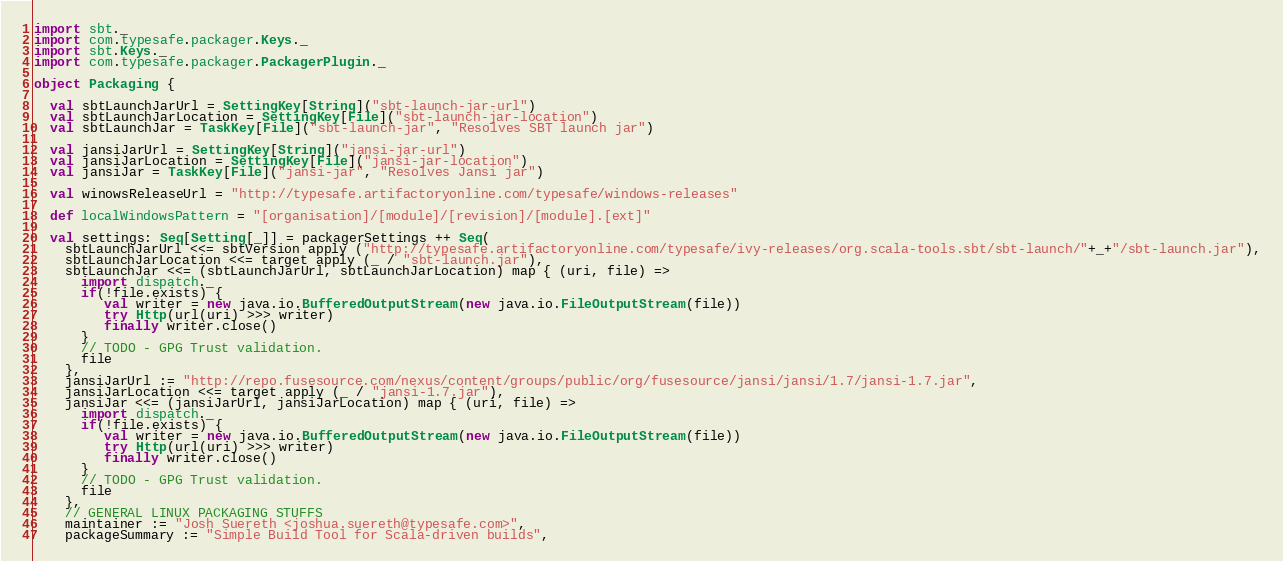Convert code to text. <code><loc_0><loc_0><loc_500><loc_500><_Scala_>import sbt._
import com.typesafe.packager.Keys._
import sbt.Keys._
import com.typesafe.packager.PackagerPlugin._

object Packaging {

  val sbtLaunchJarUrl = SettingKey[String]("sbt-launch-jar-url")
  val sbtLaunchJarLocation = SettingKey[File]("sbt-launch-jar-location")  
  val sbtLaunchJar = TaskKey[File]("sbt-launch-jar", "Resolves SBT launch jar")

  val jansiJarUrl = SettingKey[String]("jansi-jar-url")
  val jansiJarLocation = SettingKey[File]("jansi-jar-location")  
  val jansiJar = TaskKey[File]("jansi-jar", "Resolves Jansi jar")

  val winowsReleaseUrl = "http://typesafe.artifactoryonline.com/typesafe/windows-releases"

  def localWindowsPattern = "[organisation]/[module]/[revision]/[module].[ext]"
  
  val settings: Seq[Setting[_]] = packagerSettings ++ Seq(
    sbtLaunchJarUrl <<= sbtVersion apply ("http://typesafe.artifactoryonline.com/typesafe/ivy-releases/org.scala-tools.sbt/sbt-launch/"+_+"/sbt-launch.jar"),
    sbtLaunchJarLocation <<= target apply (_ / "sbt-launch.jar"),
    sbtLaunchJar <<= (sbtLaunchJarUrl, sbtLaunchJarLocation) map { (uri, file) =>
      import dispatch._
      if(!file.exists) {
         val writer = new java.io.BufferedOutputStream(new java.io.FileOutputStream(file))
         try Http(url(uri) >>> writer)
         finally writer.close()
      }
      // TODO - GPG Trust validation.
      file
    },
    jansiJarUrl := "http://repo.fusesource.com/nexus/content/groups/public/org/fusesource/jansi/jansi/1.7/jansi-1.7.jar",
    jansiJarLocation <<= target apply (_ / "jansi-1.7.jar"),
    jansiJar <<= (jansiJarUrl, jansiJarLocation) map { (uri, file) =>
      import dispatch._
      if(!file.exists) {
         val writer = new java.io.BufferedOutputStream(new java.io.FileOutputStream(file))
         try Http(url(uri) >>> writer)
         finally writer.close()
      }
      // TODO - GPG Trust validation.
      file
    },
    // GENERAL LINUX PACKAGING STUFFS
    maintainer := "Josh Suereth <joshua.suereth@typesafe.com>",
    packageSummary := "Simple Build Tool for Scala-driven builds",</code> 